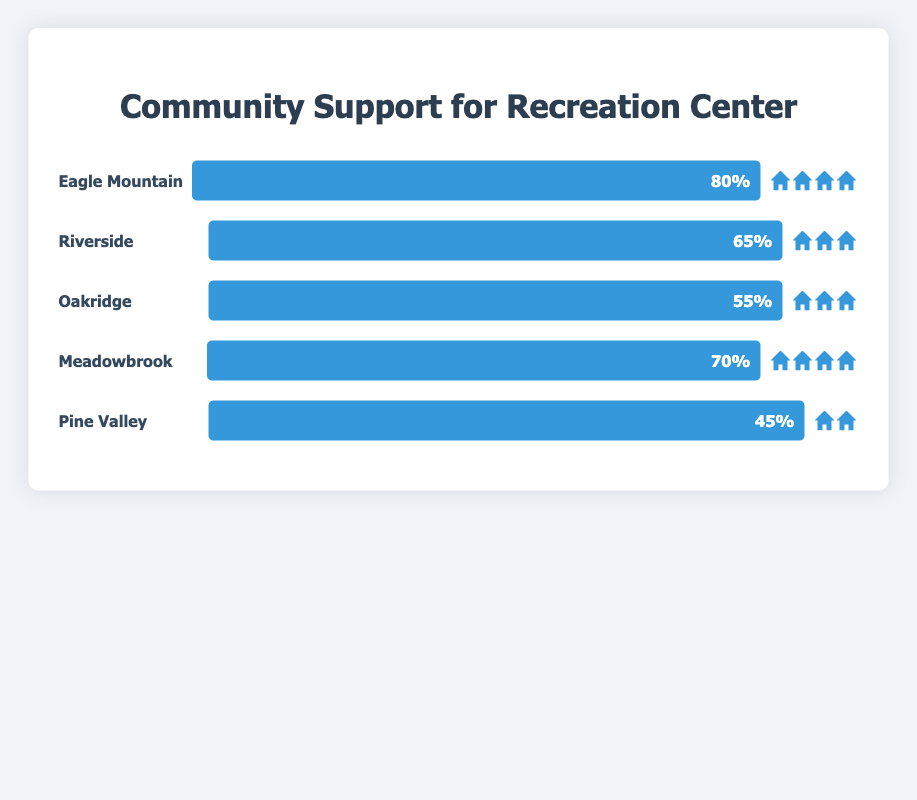What is the title of the figure? The title is located at the top of the figure in a larger font and typically summarizes the content of the chart. In this case, it reads "Community Support for Recreation Center".
Answer: Community Support for Recreation Center Which neighborhood has the highest support for the recreation center? By comparing the width of the support bars for all neighborhoods, the widest bar belongs to Eagle Mountain with 80%.
Answer: Eagle Mountain What is the difference in support between Meadowbrook and Pine Valley? Meadowbrook shows a support of 70%, and Pine Valley shows 45%. By subtracting 45 from 70, we get the difference.
Answer: 25% How many neighborhoods have support levels of 65% or higher? By checking the support levels of all neighborhoods, we notice Eagle Mountain (80%), Riverside (65%), and Meadowbrook (70%) meet the criteria.
Answer: 3 Which neighborhood has the lowest support for the recreation center project? Pine Valley shows the lowest support bar with 45%.
Answer: Pine Valley Compare the support levels between Riverside and Oakridge. Which one has higher support? By examining the support bars, Riverside shows 65% and Oakridge shows 55%. Riverside is clearly higher.
Answer: Riverside What is the average support for the recreation center across all neighborhoods? The support levels are as follows: Eagle Mountain (80%), Riverside (65%), Oakridge (55%), Meadowbrook (70%), Pine Valley (45%). Summing these gives 315. Dividing by 5 yields an average of 63%.
Answer: 63% How many neighborhoods have at least three support icons? Only Eagle Mountain, Riverside, Oakridge, and Meadowbrook show at least three icons each. Pine Valley has only two.
Answer: 4 Which neighborhood has exactly four support icons? By counting the icons next to each neighborhood, both Eagle Mountain and Meadowbrook show exactly four support icons each.
Answer: Eagle Mountain and Meadowbrook Is the support for the recreation center over 50% in Oakridge? The support bar for Oakridge reads 55%, which is over 50%.
Answer: Yes 